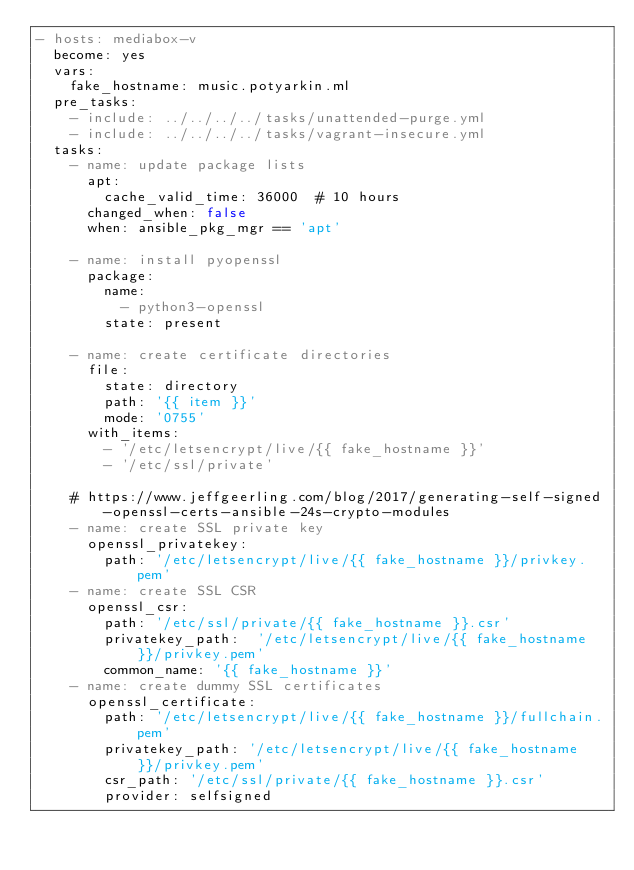<code> <loc_0><loc_0><loc_500><loc_500><_YAML_>- hosts: mediabox-v
  become: yes
  vars:
    fake_hostname: music.potyarkin.ml
  pre_tasks:
    - include: ../../../../tasks/unattended-purge.yml
    - include: ../../../../tasks/vagrant-insecure.yml
  tasks:
    - name: update package lists
      apt:
        cache_valid_time: 36000  # 10 hours
      changed_when: false
      when: ansible_pkg_mgr == 'apt'

    - name: install pyopenssl
      package:
        name:
          - python3-openssl
        state: present

    - name: create certificate directories
      file:
        state: directory
        path: '{{ item }}'
        mode: '0755'
      with_items:
        - '/etc/letsencrypt/live/{{ fake_hostname }}'
        - '/etc/ssl/private'

    # https://www.jeffgeerling.com/blog/2017/generating-self-signed-openssl-certs-ansible-24s-crypto-modules
    - name: create SSL private key
      openssl_privatekey:
        path: '/etc/letsencrypt/live/{{ fake_hostname }}/privkey.pem'
    - name: create SSL CSR
      openssl_csr:
        path: '/etc/ssl/private/{{ fake_hostname }}.csr'
        privatekey_path:  '/etc/letsencrypt/live/{{ fake_hostname }}/privkey.pem'
        common_name: '{{ fake_hostname }}'
    - name: create dummy SSL certificates
      openssl_certificate:
        path: '/etc/letsencrypt/live/{{ fake_hostname }}/fullchain.pem'
        privatekey_path: '/etc/letsencrypt/live/{{ fake_hostname }}/privkey.pem'
        csr_path: '/etc/ssl/private/{{ fake_hostname }}.csr'
        provider: selfsigned
</code> 